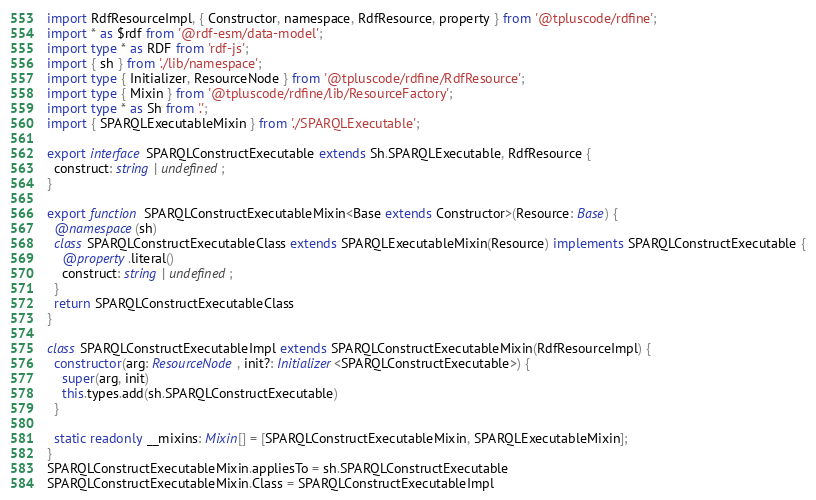<code> <loc_0><loc_0><loc_500><loc_500><_TypeScript_>import RdfResourceImpl, { Constructor, namespace, RdfResource, property } from '@tpluscode/rdfine';
import * as $rdf from '@rdf-esm/data-model';
import type * as RDF from 'rdf-js';
import { sh } from './lib/namespace';
import type { Initializer, ResourceNode } from '@tpluscode/rdfine/RdfResource';
import type { Mixin } from '@tpluscode/rdfine/lib/ResourceFactory';
import type * as Sh from '.';
import { SPARQLExecutableMixin } from './SPARQLExecutable';

export interface SPARQLConstructExecutable extends Sh.SPARQLExecutable, RdfResource {
  construct: string | undefined;
}

export function SPARQLConstructExecutableMixin<Base extends Constructor>(Resource: Base) {
  @namespace(sh)
  class SPARQLConstructExecutableClass extends SPARQLExecutableMixin(Resource) implements SPARQLConstructExecutable {
    @property.literal()
    construct: string | undefined;
  }
  return SPARQLConstructExecutableClass
}

class SPARQLConstructExecutableImpl extends SPARQLConstructExecutableMixin(RdfResourceImpl) {
  constructor(arg: ResourceNode, init?: Initializer<SPARQLConstructExecutable>) {
    super(arg, init)
    this.types.add(sh.SPARQLConstructExecutable)
  }

  static readonly __mixins: Mixin[] = [SPARQLConstructExecutableMixin, SPARQLExecutableMixin];
}
SPARQLConstructExecutableMixin.appliesTo = sh.SPARQLConstructExecutable
SPARQLConstructExecutableMixin.Class = SPARQLConstructExecutableImpl
</code> 